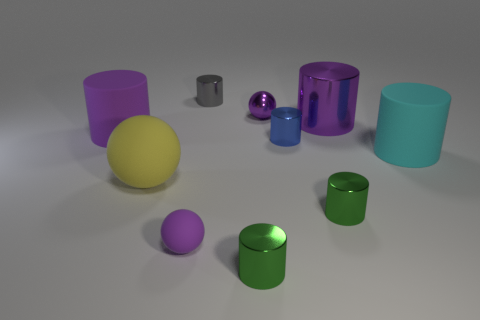What size is the purple ball that is made of the same material as the tiny gray object?
Provide a succinct answer. Small. Is there a big rubber object of the same color as the tiny matte thing?
Provide a short and direct response. Yes. What number of objects are either cylinders in front of the small gray thing or purple matte spheres?
Keep it short and to the point. 7. Is the cyan thing made of the same material as the sphere that is on the right side of the tiny gray metallic cylinder?
Provide a succinct answer. No. The shiny cylinder that is the same color as the small metal sphere is what size?
Offer a terse response. Large. Are there any small red objects made of the same material as the tiny blue thing?
Make the answer very short. No. What number of things are small objects that are on the right side of the tiny gray object or purple objects in front of the tiny purple metal thing?
Offer a terse response. 7. Does the cyan rubber thing have the same shape as the small thing on the right side of the blue metallic cylinder?
Make the answer very short. Yes. What number of other things are there of the same shape as the yellow matte thing?
Keep it short and to the point. 2. What number of objects are either large yellow metal blocks or tiny green metallic cylinders?
Your answer should be very brief. 2. 